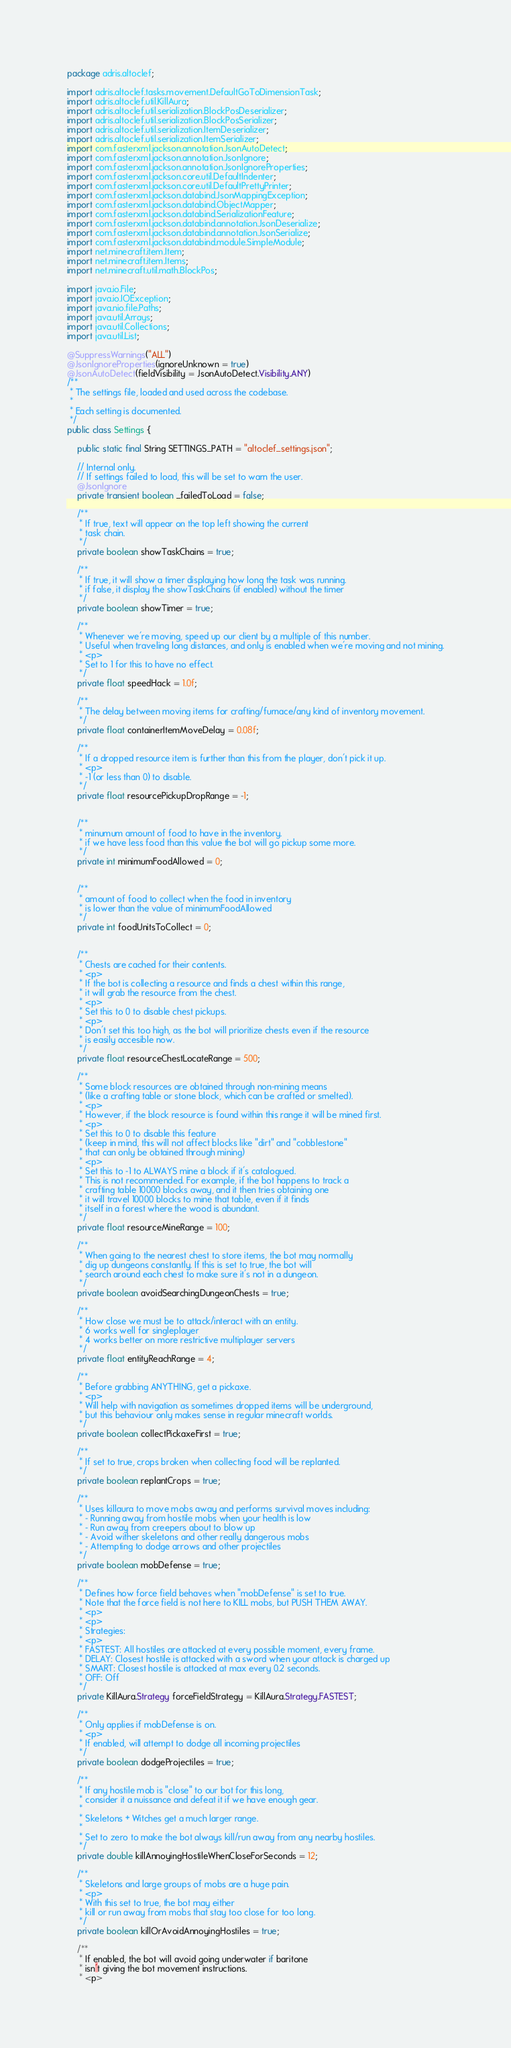<code> <loc_0><loc_0><loc_500><loc_500><_Java_>package adris.altoclef;

import adris.altoclef.tasks.movement.DefaultGoToDimensionTask;
import adris.altoclef.util.KillAura;
import adris.altoclef.util.serialization.BlockPosDeserializer;
import adris.altoclef.util.serialization.BlockPosSerializer;
import adris.altoclef.util.serialization.ItemDeserializer;
import adris.altoclef.util.serialization.ItemSerializer;
import com.fasterxml.jackson.annotation.JsonAutoDetect;
import com.fasterxml.jackson.annotation.JsonIgnore;
import com.fasterxml.jackson.annotation.JsonIgnoreProperties;
import com.fasterxml.jackson.core.util.DefaultIndenter;
import com.fasterxml.jackson.core.util.DefaultPrettyPrinter;
import com.fasterxml.jackson.databind.JsonMappingException;
import com.fasterxml.jackson.databind.ObjectMapper;
import com.fasterxml.jackson.databind.SerializationFeature;
import com.fasterxml.jackson.databind.annotation.JsonDeserialize;
import com.fasterxml.jackson.databind.annotation.JsonSerialize;
import com.fasterxml.jackson.databind.module.SimpleModule;
import net.minecraft.item.Item;
import net.minecraft.item.Items;
import net.minecraft.util.math.BlockPos;

import java.io.File;
import java.io.IOException;
import java.nio.file.Paths;
import java.util.Arrays;
import java.util.Collections;
import java.util.List;

@SuppressWarnings("ALL")
@JsonIgnoreProperties(ignoreUnknown = true)
@JsonAutoDetect(fieldVisibility = JsonAutoDetect.Visibility.ANY)
/**
 * The settings file, loaded and used across the codebase.
 *
 * Each setting is documented.
 */
public class Settings {

    public static final String SETTINGS_PATH = "altoclef_settings.json";

    // Internal only.
    // If settings failed to load, this will be set to warn the user.
    @JsonIgnore
    private transient boolean _failedToLoad = false;

    /**
     * If true, text will appear on the top left showing the current
     * task chain.
     */
    private boolean showTaskChains = true;

    /**
     * If true, it will show a timer displaying how long the task was running.
     * if false, it display the showTaskChains (if enabled) without the timer
     */
    private boolean showTimer = true;

    /**
     * Whenever we're moving, speed up our client by a multiple of this number.
     * Useful when traveling long distances, and only is enabled when we're moving and not mining.
     * <p>
     * Set to 1 for this to have no effect.
     */
    private float speedHack = 1.0f;

    /**
     * The delay between moving items for crafting/furnace/any kind of inventory movement.
     */
    private float containerItemMoveDelay = 0.08f;

    /**
     * If a dropped resource item is further than this from the player, don't pick it up.
     * <p>
     * -1 (or less than 0) to disable.
     */
    private float resourcePickupDropRange = -1;


    /**
     * minumum amount of food to have in the inventory.
     * if we have less food than this value the bot will go pickup some more.
     */
    private int minimumFoodAllowed = 0;


    /**
     * amount of food to collect when the food in inventory
     * is lower than the value of minimumFoodAllowed
     */
    private int foodUnitsToCollect = 0;


    /**
     * Chests are cached for their contents.
     * <p>
     * If the bot is collecting a resource and finds a chest within this range,
     * it will grab the resource from the chest.
     * <p>
     * Set this to 0 to disable chest pickups.
     * <p>
     * Don't set this too high, as the bot will prioritize chests even if the resource
     * is easily accesible now.
     */
    private float resourceChestLocateRange = 500;

    /**
     * Some block resources are obtained through non-mining means
     * (like a crafting table or stone block, which can be crafted or smelted).
     * <p>
     * However, if the block resource is found within this range it will be mined first.
     * <p>
     * Set this to 0 to disable this feature
     * (keep in mind, this will not affect blocks like "dirt" and "cobblestone"
     * that can only be obtained through mining)
     * <p>
     * Set this to -1 to ALWAYS mine a block if it's catalogued.
     * This is not recommended. For example, if the bot happens to track a
     * crafting table 10000 blocks away, and it then tries obtaining one
     * it will travel 10000 blocks to mine that table, even if it finds
     * itself in a forest where the wood is abundant.
     */
    private float resourceMineRange = 100;

    /**
     * When going to the nearest chest to store items, the bot may normally
     * dig up dungeons constantly. If this is set to true, the bot will
     * search around each chest to make sure it's not in a dungeon.
     */
    private boolean avoidSearchingDungeonChests = true;

    /**
     * How close we must be to attack/interact with an entity.
     * 6 works well for singleplayer
     * 4 works better on more restrictive multiplayer servers
     */
    private float entityReachRange = 4;

    /**
     * Before grabbing ANYTHING, get a pickaxe.
     * <p>
     * Will help with navigation as sometimes dropped items will be underground,
     * but this behaviour only makes sense in regular minecraft worlds.
     */
    private boolean collectPickaxeFirst = true;

    /**
     * If set to true, crops broken when collecting food will be replanted.
     */
    private boolean replantCrops = true;

    /**
     * Uses killaura to move mobs away and performs survival moves including:
     * - Running away from hostile mobs when your health is low
     * - Run away from creepers about to blow up
     * - Avoid wither skeletons and other really dangerous mobs
     * - Attempting to dodge arrows and other projectiles
     */
    private boolean mobDefense = true;

    /**
     * Defines how force field behaves when "mobDefense" is set to true.
     * Note that the force field is not here to KILL mobs, but PUSH THEM AWAY.
     * <p>
     * <p>
     * Strategies:
     * <p>
     * FASTEST: All hostiles are attacked at every possible moment, every frame.
     * DELAY: Closest hostile is attacked with a sword when your attack is charged up
     * SMART: Closest hostile is attacked at max every 0.2 seconds.
     * OFF: Off
     */
    private KillAura.Strategy forceFieldStrategy = KillAura.Strategy.FASTEST;

    /**
     * Only applies if mobDefense is on.
     * <p>
     * If enabled, will attempt to dodge all incoming projectiles
     */
    private boolean dodgeProjectiles = true;

    /**
     * If any hostile mob is "close" to our bot for this long,
     * consider it a nuissance and defeat it if we have enough gear.
     *
     * Skeletons + Witches get a much larger range.
     *
     * Set to zero to make the bot always kill/run away from any nearby hostiles.
     */
    private double killAnnoyingHostileWhenCloseForSeconds = 12;

    /**
     * Skeletons and large groups of mobs are a huge pain.
     * <p>
     * With this set to true, the bot may either
     * kill or run away from mobs that stay too close for too long.
     */
    private boolean killOrAvoidAnnoyingHostiles = true;

    /**
     * If enabled, the bot will avoid going underwater if baritone
     * isn't giving the bot movement instructions.
     * <p></code> 